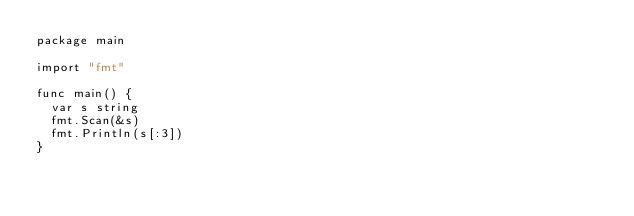<code> <loc_0><loc_0><loc_500><loc_500><_Go_>package main

import "fmt"

func main() {
	var s string
	fmt.Scan(&s)
	fmt.Println(s[:3])
}
</code> 